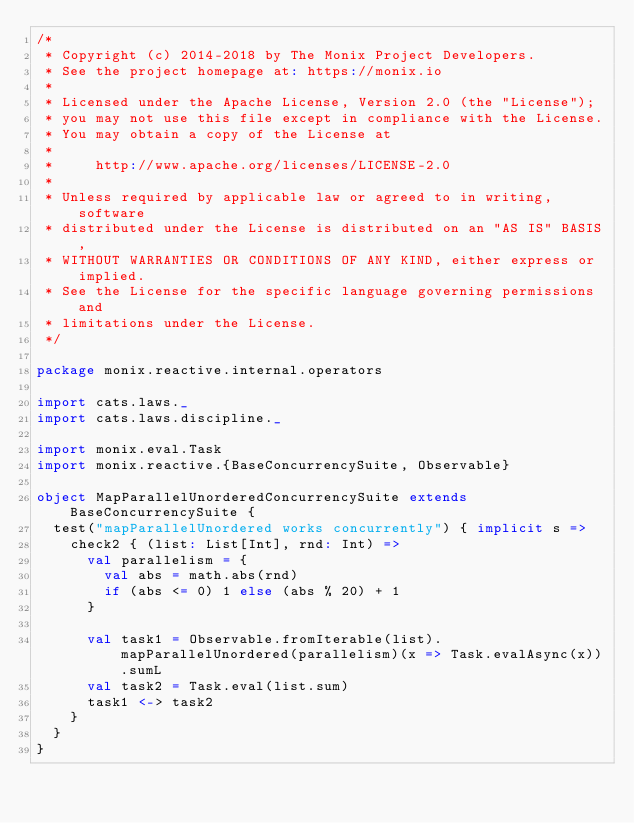Convert code to text. <code><loc_0><loc_0><loc_500><loc_500><_Scala_>/*
 * Copyright (c) 2014-2018 by The Monix Project Developers.
 * See the project homepage at: https://monix.io
 *
 * Licensed under the Apache License, Version 2.0 (the "License");
 * you may not use this file except in compliance with the License.
 * You may obtain a copy of the License at
 *
 *     http://www.apache.org/licenses/LICENSE-2.0
 *
 * Unless required by applicable law or agreed to in writing, software
 * distributed under the License is distributed on an "AS IS" BASIS,
 * WITHOUT WARRANTIES OR CONDITIONS OF ANY KIND, either express or implied.
 * See the License for the specific language governing permissions and
 * limitations under the License.
 */

package monix.reactive.internal.operators

import cats.laws._
import cats.laws.discipline._

import monix.eval.Task
import monix.reactive.{BaseConcurrencySuite, Observable}

object MapParallelUnorderedConcurrencySuite extends BaseConcurrencySuite {
  test("mapParallelUnordered works concurrently") { implicit s =>
    check2 { (list: List[Int], rnd: Int) =>
      val parallelism = {
        val abs = math.abs(rnd)
        if (abs <= 0) 1 else (abs % 20) + 1
      }

      val task1 = Observable.fromIterable(list).mapParallelUnordered(parallelism)(x => Task.evalAsync(x)).sumL
      val task2 = Task.eval(list.sum)
      task1 <-> task2
    }
  }
}
</code> 